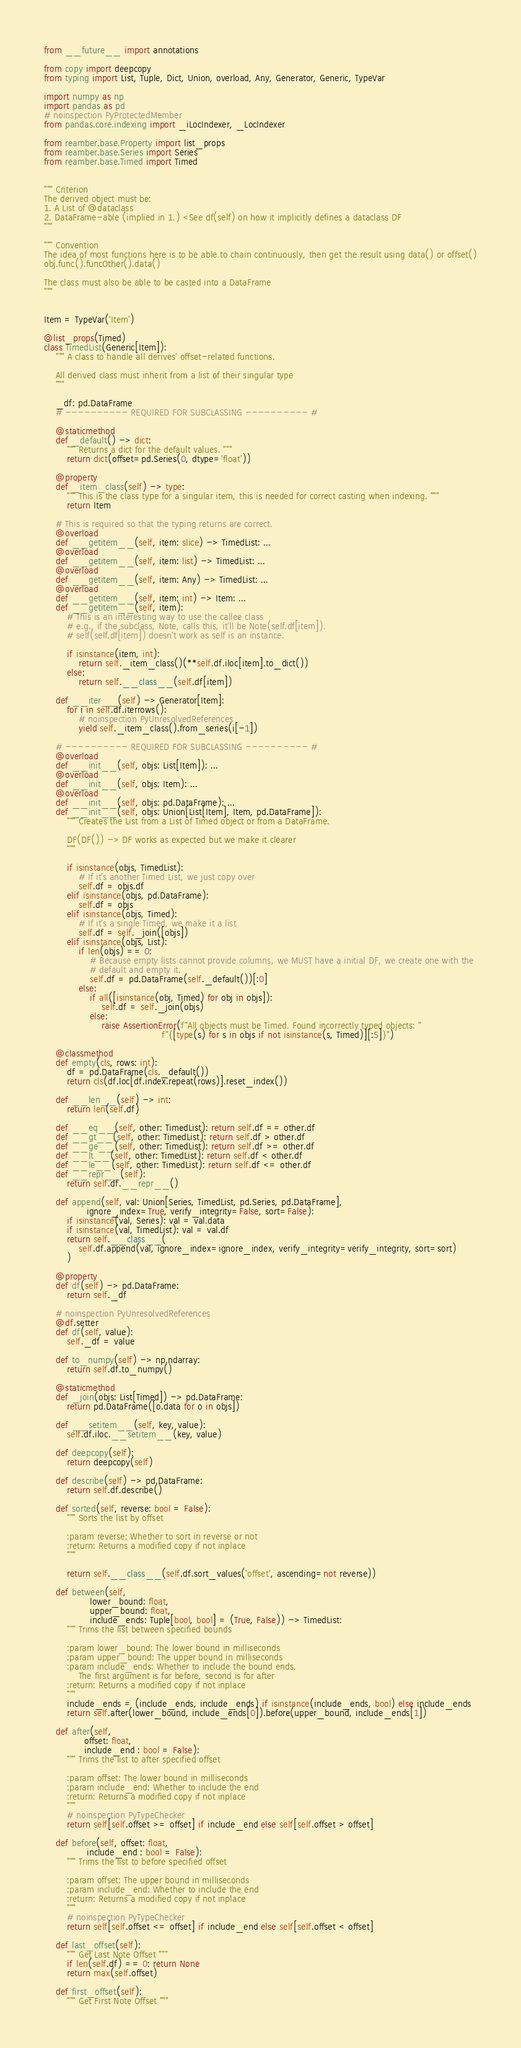Convert code to text. <code><loc_0><loc_0><loc_500><loc_500><_Python_>from __future__ import annotations

from copy import deepcopy
from typing import List, Tuple, Dict, Union, overload, Any, Generator, Generic, TypeVar

import numpy as np
import pandas as pd
# noinspection PyProtectedMember
from pandas.core.indexing import _iLocIndexer, _LocIndexer

from reamber.base.Property import list_props
from reamber.base.Series import Series
from reamber.base.Timed import Timed


""" Criterion
The derived object must be:
1. A List of @dataclass
2. DataFrame-able (implied in 1.) <See df(self) on how it implicitly defines a dataclass DF
"""

""" Convention
The idea of most functions here is to be able to chain continuously, then get the result using data() or offset()
obj.func().funcOther().data()

The class must also be able to be casted into a DataFrame
"""


Item = TypeVar('Item')

@list_props(Timed)
class TimedList(Generic[Item]):
    """ A class to handle all derives' offset-related functions.

    All derived class must inherit from a list of their singular type
    """

    _df: pd.DataFrame
    # ---------- REQUIRED FOR SUBCLASSING ---------- #

    @staticmethod
    def _default() -> dict:
        """ Returns a dict for the default values. """
        return dict(offset=pd.Series(0, dtype='float'))

    @property
    def _item_class(self) -> type:
        """ This is the class type for a singular item, this is needed for correct casting when indexing. """
        return Item

    # This is required so that the typing returns are correct.
    @overload
    def __getitem__(self, item: slice) -> TimedList: ...
    @overload
    def __getitem__(self, item: list) -> TimedList: ...
    @overload
    def __getitem__(self, item: Any) -> TimedList: ...
    @overload
    def __getitem__(self, item: int) -> Item: ...
    def __getitem__(self, item):
        # This is an interesting way to use the callee class
        # e.g., if the subclass, Note, calls this, it'll be Note(self.df[item]).
        # self(self.df[item]) doesn't work as self is an instance.

        if isinstance(item, int):
            return self._item_class()(**self.df.iloc[item].to_dict())
        else:
            return self.__class__(self.df[item])

    def __iter__(self) -> Generator[Item]:
        for i in self.df.iterrows():
            # noinspection PyUnresolvedReferences
            yield self._item_class().from_series(i[-1])

    # ---------- REQUIRED FOR SUBCLASSING ---------- #
    @overload
    def __init__(self, objs: List[Item]): ...
    @overload
    def __init__(self, objs: Item): ...
    @overload
    def __init__(self, objs: pd.DataFrame): ...
    def __init__(self, objs: Union[List[Item], Item, pd.DataFrame]):
        """ Creates the List from a List of Timed object or from a DataFrame.

        DF(DF()) -> DF works as expected but we make it clearer
        """

        if isinstance(objs, TimedList):
            # If it's another Timed List, we just copy over
            self.df = objs.df
        elif isinstance(objs, pd.DataFrame):
            self.df = objs
        elif isinstance(objs, Timed):
            # If it's a single Timed, we make it a list
            self.df = self._join([objs])
        elif isinstance(objs, List):
            if len(objs) == 0:
                # Because empty lists cannot provide columns, we MUST have a initial DF, we create one with the
                # default and empty it.
                self.df = pd.DataFrame(self._default())[:0]
            else:
                if all([isinstance(obj, Timed) for obj in objs]):
                    self.df = self._join(objs)
                else:
                    raise AssertionError(f"All objects must be Timed. Found incorrectly typed objects: "
                                         f"{[type(s) for s in objs if not isinstance(s, Timed)][:5]}")

    @classmethod
    def empty(cls, rows: int):
        df = pd.DataFrame(cls._default())
        return cls(df.loc[df.index.repeat(rows)].reset_index())

    def __len__(self) -> int:
        return len(self.df)

    def __eq__(self, other: TimedList): return self.df == other.df
    def __gt__(self, other: TimedList): return self.df > other.df
    def __ge__(self, other: TimedList): return self.df >= other.df
    def __lt__(self, other: TimedList): return self.df < other.df
    def __le__(self, other: TimedList): return self.df <= other.df
    def __repr__(self):
        return self.df.__repr__()

    def append(self, val: Union[Series, TimedList, pd.Series, pd.DataFrame],
               ignore_index=True, verify_integrity=False, sort=False):
        if isinstance(val, Series): val = val.data
        if isinstance(val, TimedList): val = val.df
        return self.__class__(
            self.df.append(val, ignore_index=ignore_index, verify_integrity=verify_integrity, sort=sort)
        )

    @property
    def df(self) -> pd.DataFrame:
        return self._df

    # noinspection PyUnresolvedReferences
    @df.setter
    def df(self, value):
        self._df = value

    def to_numpy(self) -> np.ndarray:
        return self.df.to_numpy()

    @staticmethod
    def _join(objs: List[Timed]) -> pd.DataFrame:
        return pd.DataFrame([o.data for o in objs])

    def __setitem__(self, key, value):
        self.df.iloc.__setitem__(key, value)

    def deepcopy(self):
        return deepcopy(self)

    def describe(self) -> pd.DataFrame:
        return self.df.describe()

    def sorted(self, reverse: bool = False):
        """ Sorts the list by offset

        :param reverse: Whether to sort in reverse or not
        :return: Returns a modified copy if not inplace
        """

        return self.__class__(self.df.sort_values('offset', ascending=not reverse))

    def between(self,
                lower_bound: float,
                upper_bound: float,
                include_ends: Tuple[bool, bool] = (True, False)) -> TimedList:
        """ Trims the list between specified bounds

        :param lower_bound: The lower bound in milliseconds
        :param upper_bound: The upper bound in milliseconds
        :param include_ends: Whether to include the bound ends.
            The first argument is for before, second is for after
        :return: Returns a modified copy if not inplace
        """
        include_ends = (include_ends, include_ends) if isinstance(include_ends, bool) else include_ends
        return self.after(lower_bound, include_ends[0]).before(upper_bound, include_ends[1])

    def after(self,
              offset: float,
              include_end : bool = False):
        """ Trims the list to after specified offset

        :param offset: The lower bound in milliseconds
        :param include_end: Whether to include the end
        :return: Returns a modified copy if not inplace
        """
        # noinspection PyTypeChecker
        return self[self.offset >= offset] if include_end else self[self.offset > offset]

    def before(self, offset: float,
               include_end : bool = False):
        """ Trims the list to before specified offset

        :param offset: The upper bound in milliseconds
        :param include_end: Whether to include the end
        :return: Returns a modified copy if not inplace
        """
        # noinspection PyTypeChecker
        return self[self.offset <= offset] if include_end else self[self.offset < offset]

    def last_offset(self):
        """ Get Last Note Offset """
        if len(self.df) == 0: return None
        return max(self.offset)

    def first_offset(self):
        """ Get First Note Offset """</code> 